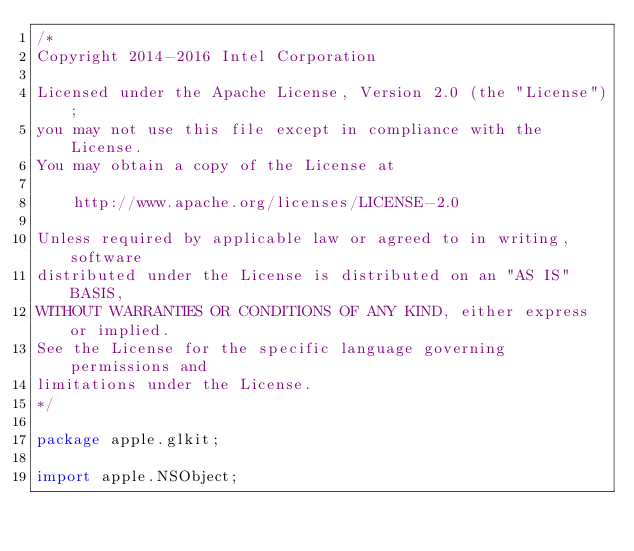Convert code to text. <code><loc_0><loc_0><loc_500><loc_500><_Java_>/*
Copyright 2014-2016 Intel Corporation

Licensed under the Apache License, Version 2.0 (the "License");
you may not use this file except in compliance with the License.
You may obtain a copy of the License at

    http://www.apache.org/licenses/LICENSE-2.0

Unless required by applicable law or agreed to in writing, software
distributed under the License is distributed on an "AS IS" BASIS,
WITHOUT WARRANTIES OR CONDITIONS OF ANY KIND, either express or implied.
See the License for the specific language governing permissions and
limitations under the License.
*/

package apple.glkit;

import apple.NSObject;</code> 